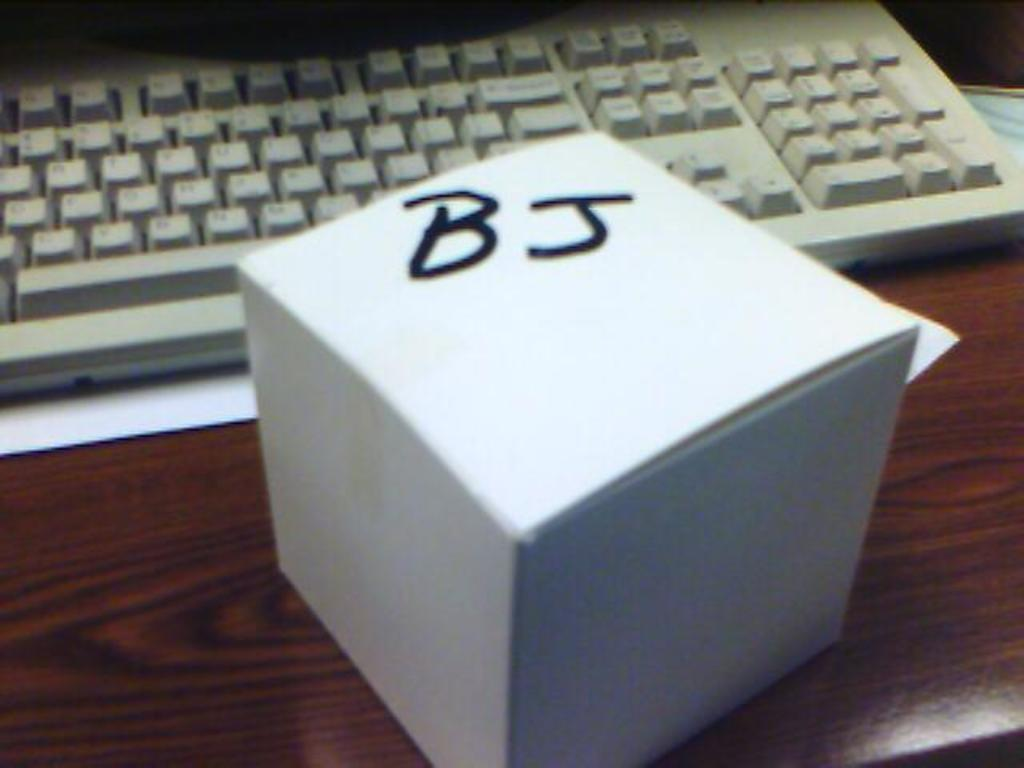<image>
Describe the image concisely. A white box with BJ written on the top is on a desk in front of a keyboard. 